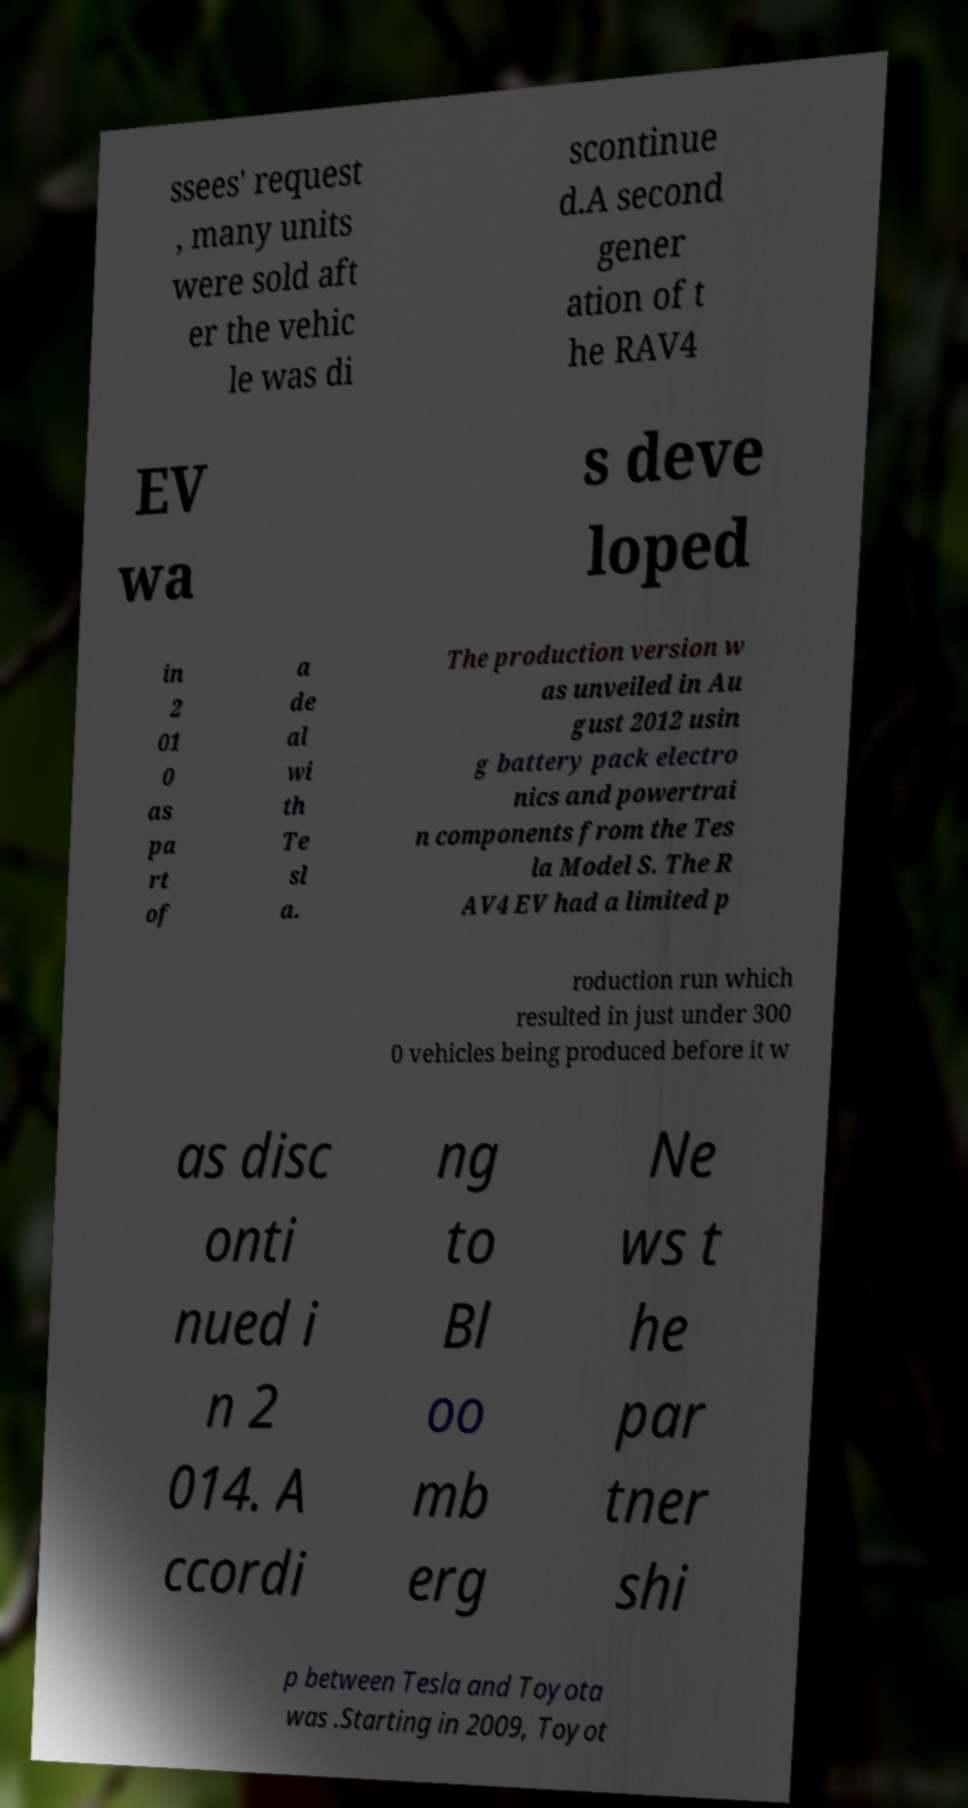Could you assist in decoding the text presented in this image and type it out clearly? ssees' request , many units were sold aft er the vehic le was di scontinue d.A second gener ation of t he RAV4 EV wa s deve loped in 2 01 0 as pa rt of a de al wi th Te sl a. The production version w as unveiled in Au gust 2012 usin g battery pack electro nics and powertrai n components from the Tes la Model S. The R AV4 EV had a limited p roduction run which resulted in just under 300 0 vehicles being produced before it w as disc onti nued i n 2 014. A ccordi ng to Bl oo mb erg Ne ws t he par tner shi p between Tesla and Toyota was .Starting in 2009, Toyot 